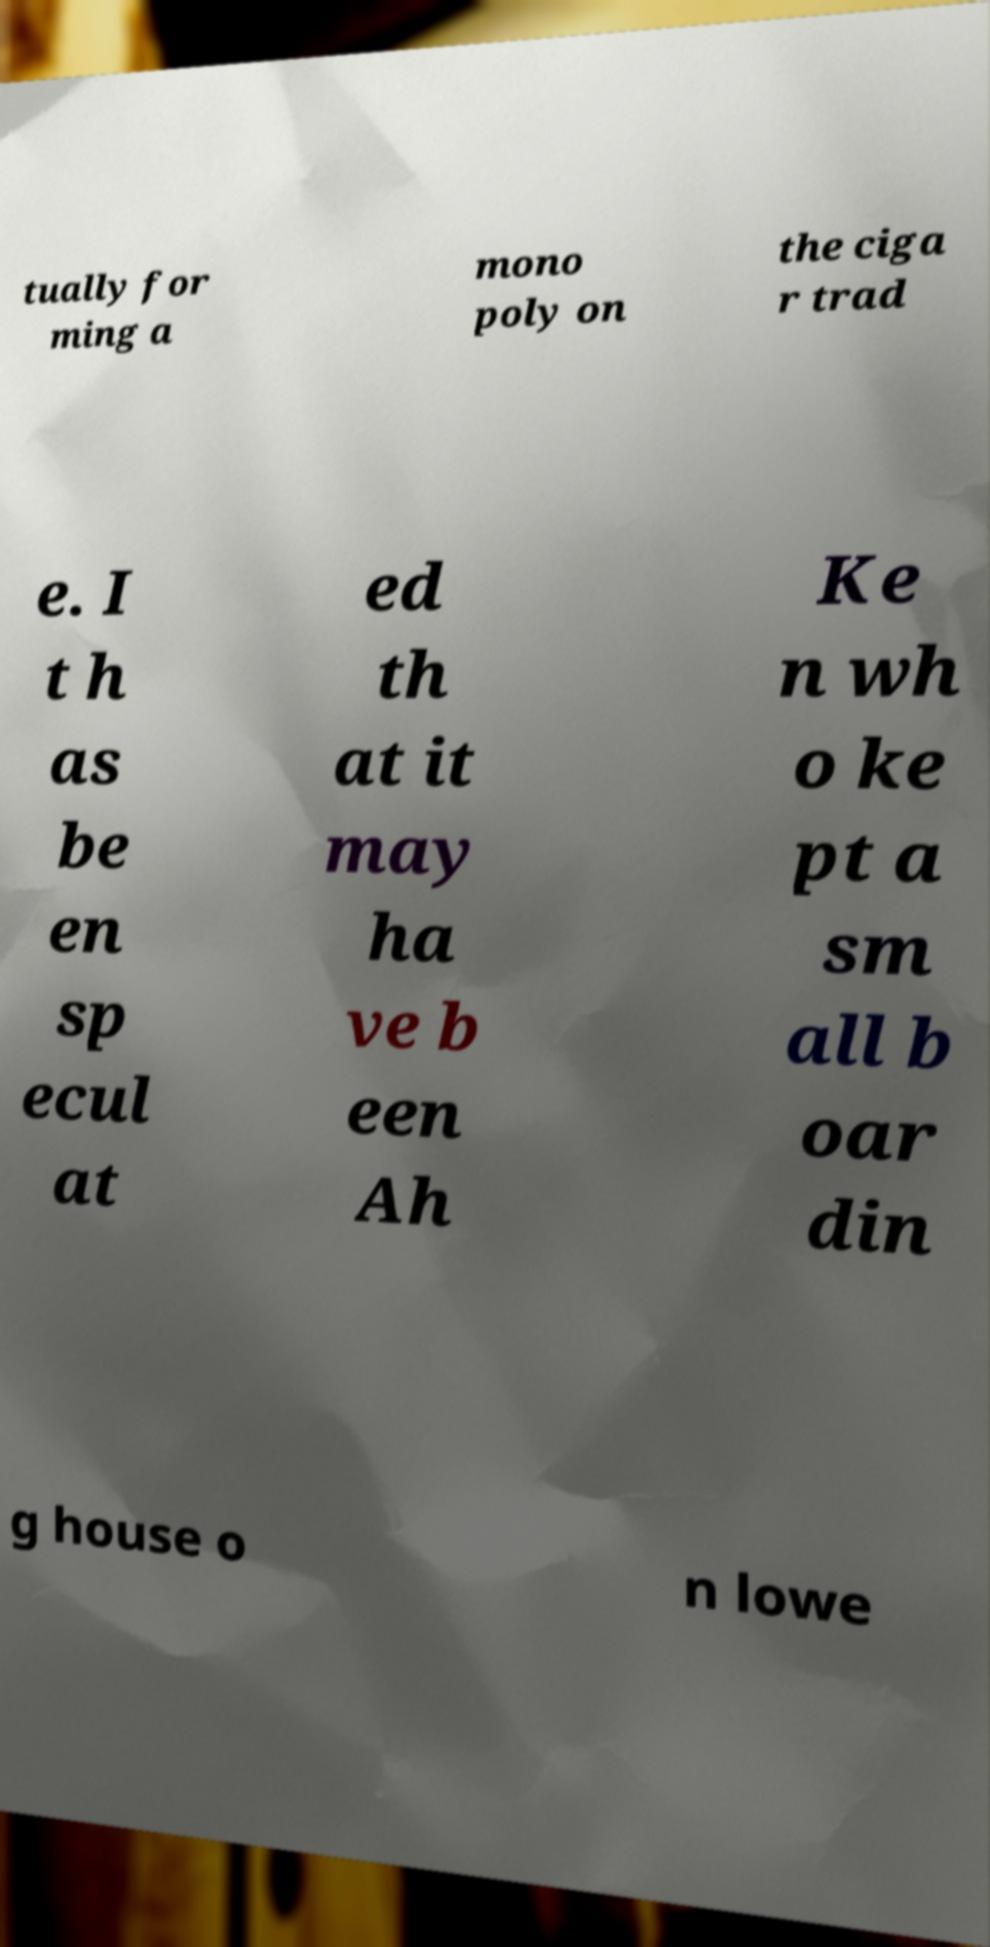Can you accurately transcribe the text from the provided image for me? tually for ming a mono poly on the ciga r trad e. I t h as be en sp ecul at ed th at it may ha ve b een Ah Ke n wh o ke pt a sm all b oar din g house o n lowe 